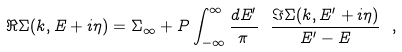<formula> <loc_0><loc_0><loc_500><loc_500>\Re \Sigma ( { k } , E + i \eta ) = \Sigma _ { \infty } + P \int _ { - \infty } ^ { \infty } \frac { d E ^ { \prime } } { \pi } \ \frac { \Im \Sigma ( { k } , E ^ { \prime } + i \eta ) } { E ^ { \prime } - E } \ ,</formula> 